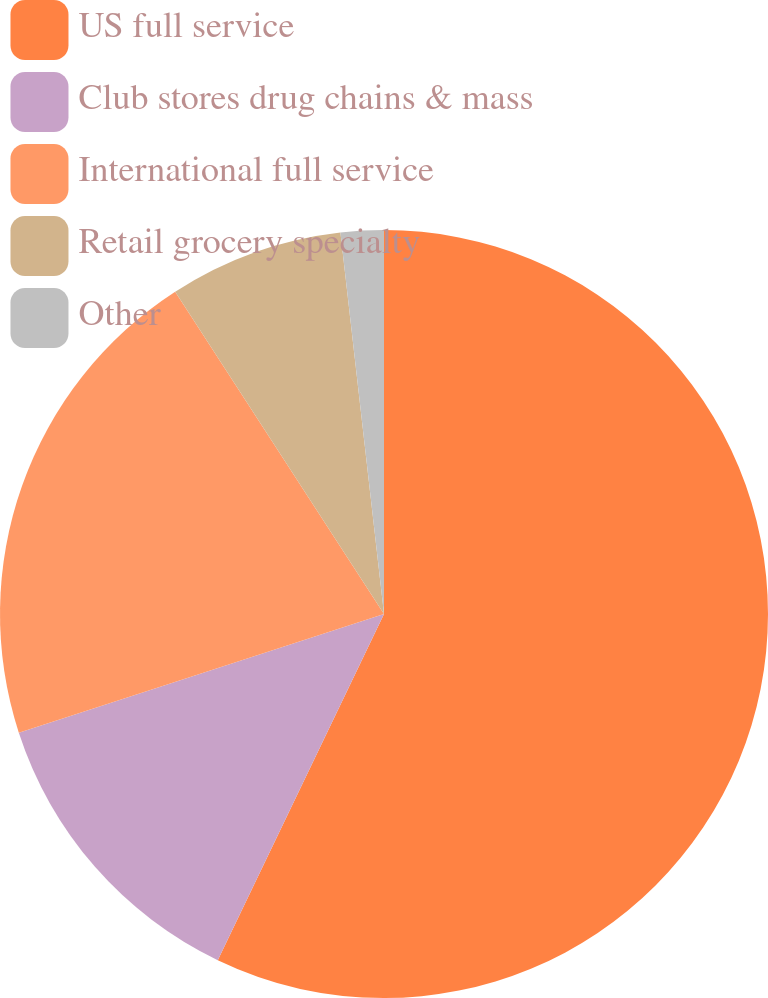Convert chart. <chart><loc_0><loc_0><loc_500><loc_500><pie_chart><fcel>US full service<fcel>Club stores drug chains & mass<fcel>International full service<fcel>Retail grocery specialty<fcel>Other<nl><fcel>57.12%<fcel>12.87%<fcel>20.85%<fcel>7.34%<fcel>1.81%<nl></chart> 